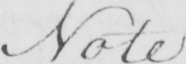Please provide the text content of this handwritten line. Note 